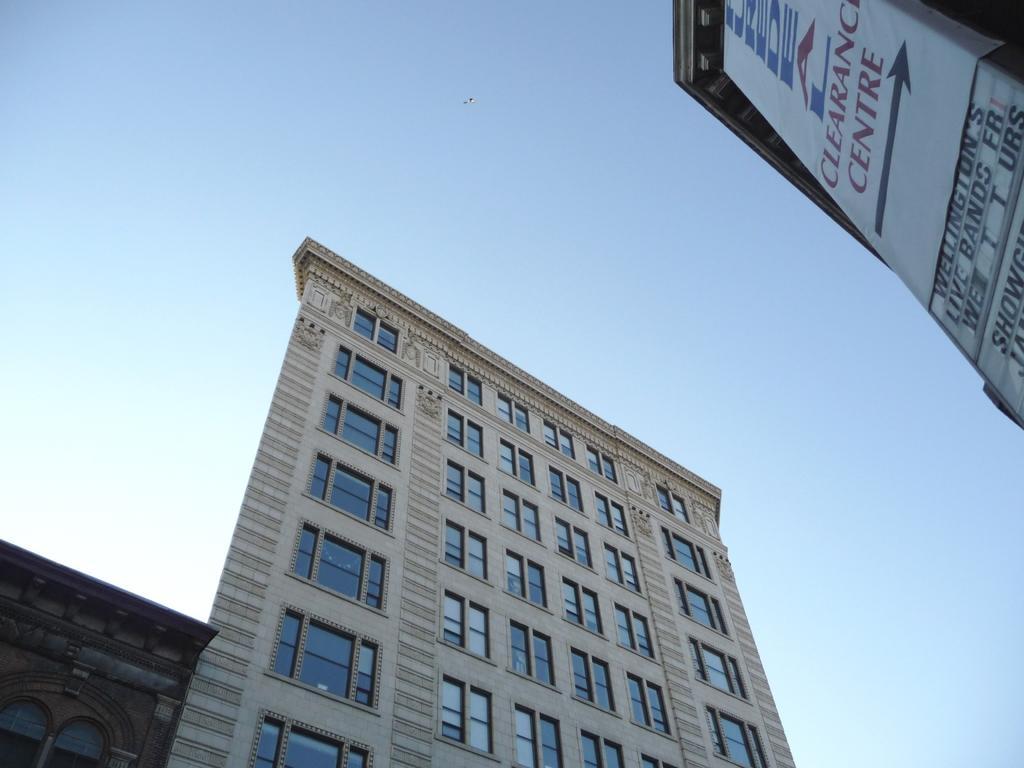Could you give a brief overview of what you see in this image? In this picture I can see the buildings, in the background there is the sky. In the top right hand side I can see the banner and the text. 